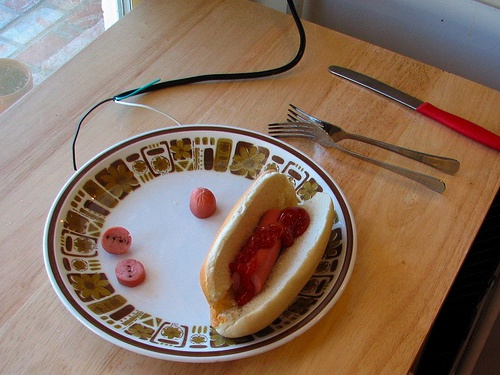Describe the objects in this image and their specific colors. I can see dining table in lightblue, darkgray, brown, and gray tones, hot dog in lightblue, maroon, olive, and darkgray tones, knife in lightblue, maroon, black, and darkgray tones, fork in lightblue, maroon, gray, and black tones, and fork in lightblue, maroon, and gray tones in this image. 